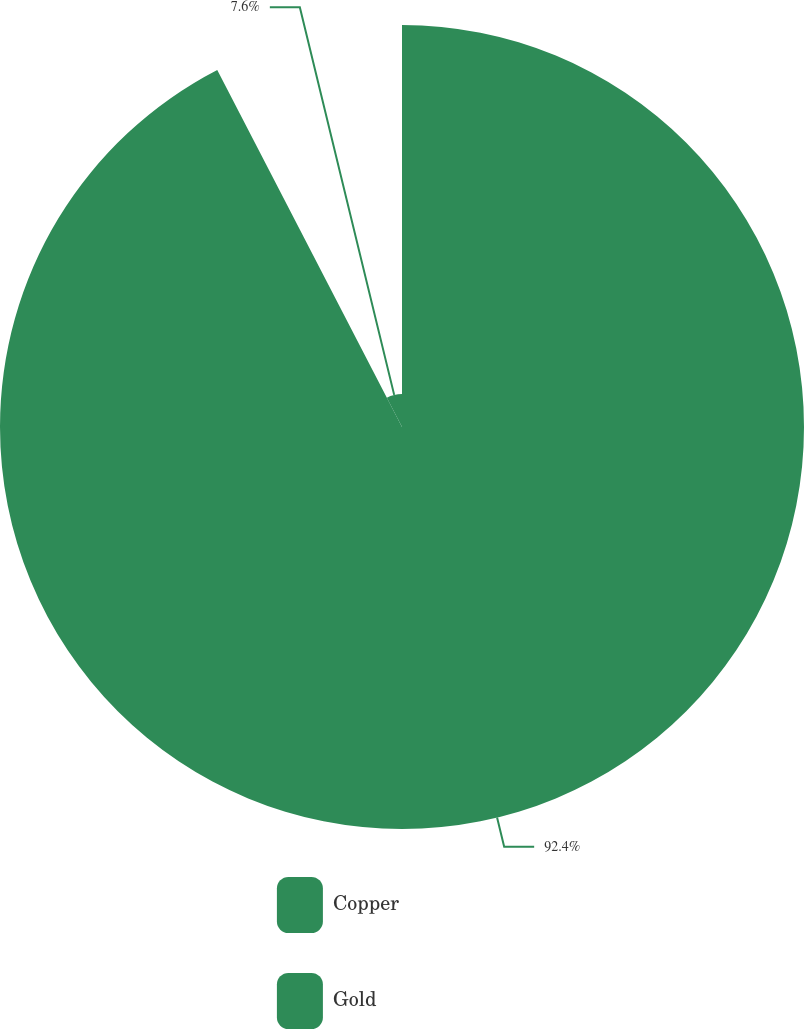Convert chart to OTSL. <chart><loc_0><loc_0><loc_500><loc_500><pie_chart><fcel>Copper<fcel>Gold<nl><fcel>92.4%<fcel>7.6%<nl></chart> 